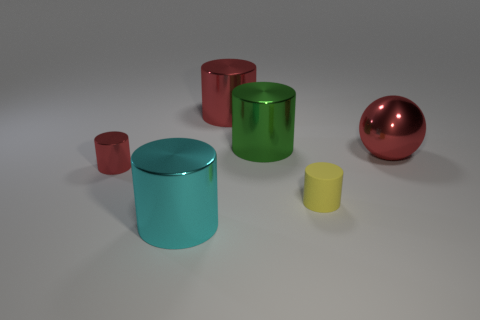Subtract all yellow cylinders. How many cylinders are left? 4 Subtract all green cylinders. How many cylinders are left? 4 Subtract all gray cylinders. Subtract all red cubes. How many cylinders are left? 5 Add 3 small yellow matte objects. How many objects exist? 9 Subtract all balls. How many objects are left? 5 Subtract all yellow blocks. Subtract all small things. How many objects are left? 4 Add 3 green metallic things. How many green metallic things are left? 4 Add 1 big red metallic objects. How many big red metallic objects exist? 3 Subtract 1 cyan cylinders. How many objects are left? 5 